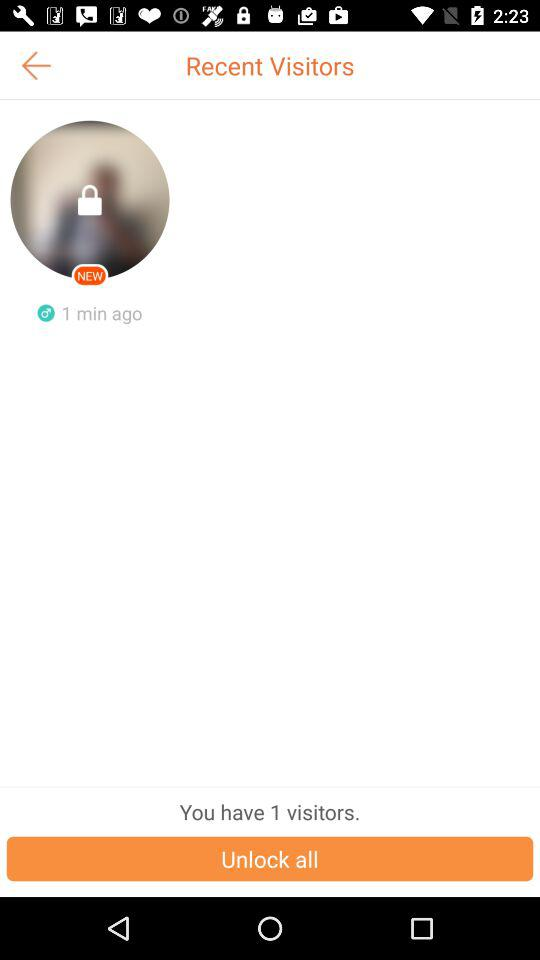When did the recent visitor visit the profile? The recent visitor visited the profile 1 minute ago. 